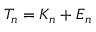Convert formula to latex. <formula><loc_0><loc_0><loc_500><loc_500>T _ { n } = K _ { n } + E _ { n }</formula> 